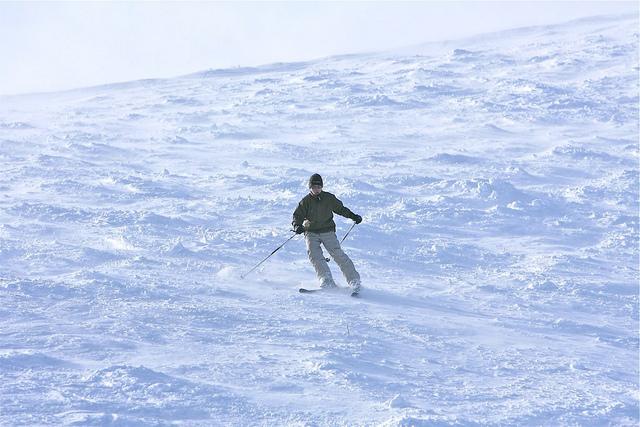Is it a cold day?
Quick response, please. Yes. Is it snowing?
Answer briefly. No. Was this picture taken in Miami, Florida?
Short answer required. No. Is this person skiing?
Give a very brief answer. Yes. What activity is the person engaging in?
Answer briefly. Skiing. Is this the first person to ski in this snow?
Keep it brief. Yes. Are the ski poles crooked?
Answer briefly. No. What sport is being shown?
Concise answer only. Skiing. 